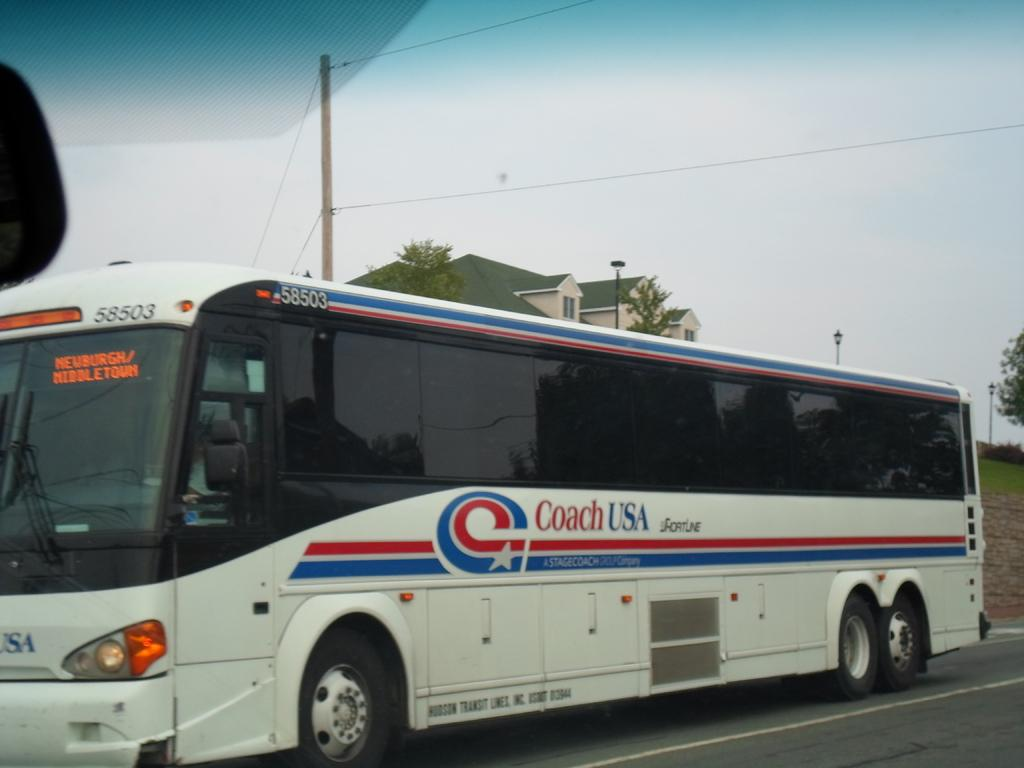What type of vehicle is on the road in the image? There is a bus on the road in the image. What type of vegetation can be seen in the image? There is grass and trees visible in the image. What type of structures can be seen in the image? There are poles and buildings visible in the image. What type of openings can be seen in the image? There are windows visible in the image. What type of infrastructure can be seen in the image? There are wires visible in the image. What is visible in the background of the image? The sky is visible in the background of the image. What type of pain is the bus experiencing in the image? The bus is not experiencing any pain in the image, as it is an inanimate object. What type of mouth can be seen on the trees in the image? There are no mouths present on the trees in the image, as trees do not have mouths. 